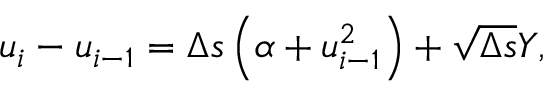<formula> <loc_0><loc_0><loc_500><loc_500>\begin{array} { r } { u _ { i } - u _ { i - 1 } = \Delta s \left ( \alpha + u _ { i - 1 } ^ { 2 } \right ) + \sqrt { \Delta s } Y , } \end{array}</formula> 